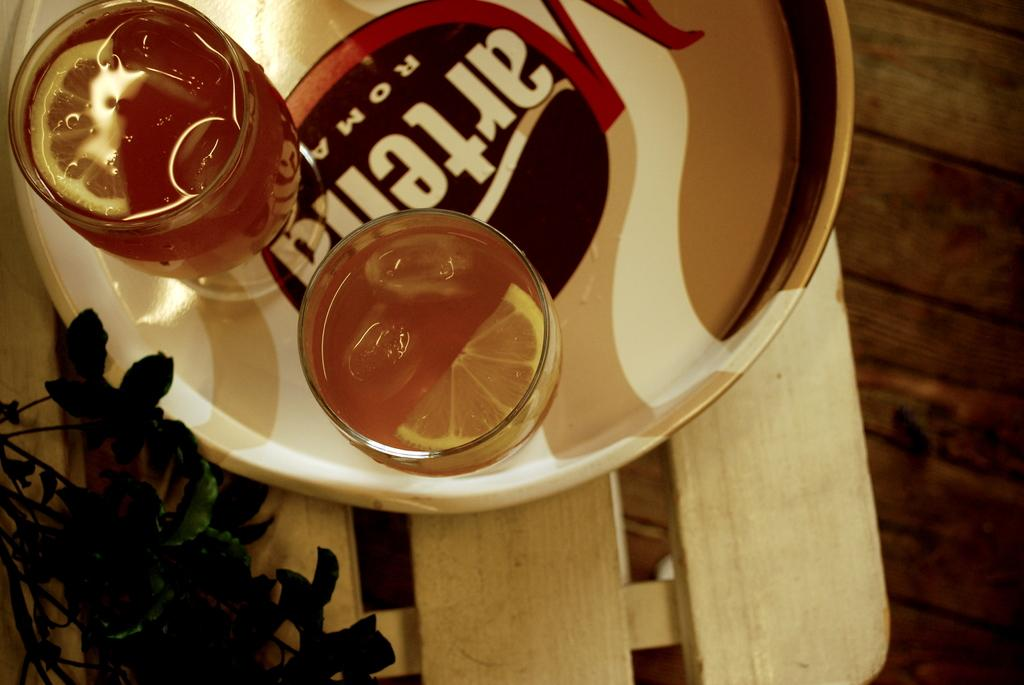What is in the glasses on the wooden table in the image? The glasses on the wooden table are filled with juice. What type of plant is on the table? There is a plant with green leaves on the table. What is the material of the table in the image? The table in the image is made of wood. What can be seen in the background of the image? There is a wooden surface in the background. What type of pump is visible in the image? There is no pump present in the image. What is the base made of in the image? There is no base mentioned in the image, only a wooden table and a wooden surface in the background. 